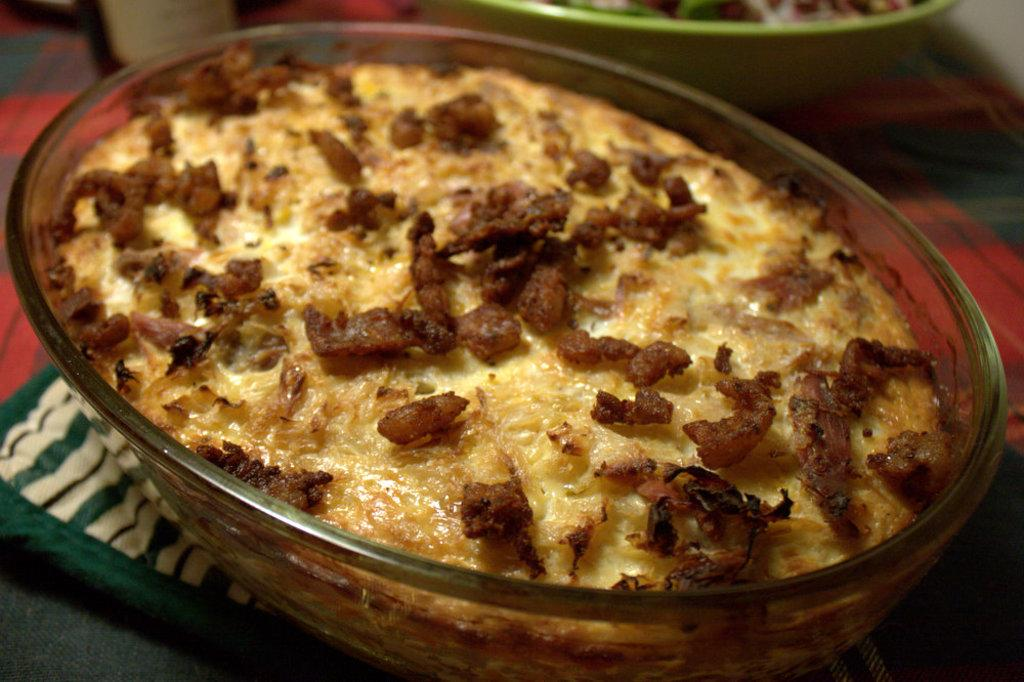What is in the bowl that is visible in the image? There is a bowl containing food in the image. Are there any other bowls present in the image? Yes, there is another bowl present at the top of the image. What can be seen in the bottom left of the image? There is a cloth in the bottom left of the image. What type of coal is being used to heat the prison in the image? There is no reference to a prison or coal in the image, so it is not possible to answer that question. 